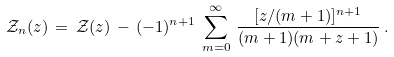<formula> <loc_0><loc_0><loc_500><loc_500>\mathcal { Z } _ { n } ( z ) \, = \, \mathcal { Z } ( z ) \, - \, ( - 1 ) ^ { n + 1 } \, \sum _ { m = 0 } ^ { \infty } \, \frac { [ z / ( m + 1 ) ] ^ { n + 1 } } { ( m + 1 ) ( m + z + 1 ) } \, .</formula> 